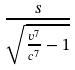<formula> <loc_0><loc_0><loc_500><loc_500>\frac { s } { \sqrt { \frac { v ^ { 7 } } { c ^ { 7 } } - 1 } }</formula> 